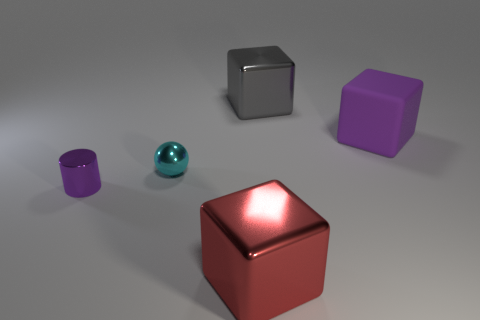What can you tell me about the lighting in the scene? The objects are illuminated by a soft overhead light that casts gentle shadows on the ground. The reflection on the objects suggests the light source is not directly visible and is diffused to create a soft effect.  Can you describe the textures of the objects? Although the image does not show close-up details, the objects appear to have smooth textures due to their reflective surfaces. This smoothness implies a lack of graininess or roughness to the touch. 